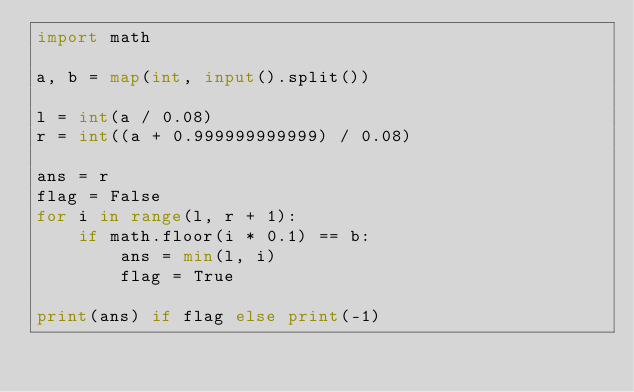<code> <loc_0><loc_0><loc_500><loc_500><_Python_>import math

a, b = map(int, input().split())

l = int(a / 0.08)
r = int((a + 0.999999999999) / 0.08)

ans = r
flag = False
for i in range(l, r + 1):
    if math.floor(i * 0.1) == b:
        ans = min(l, i)
        flag = True

print(ans) if flag else print(-1)
</code> 